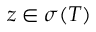<formula> <loc_0><loc_0><loc_500><loc_500>z \in \sigma ( T )</formula> 